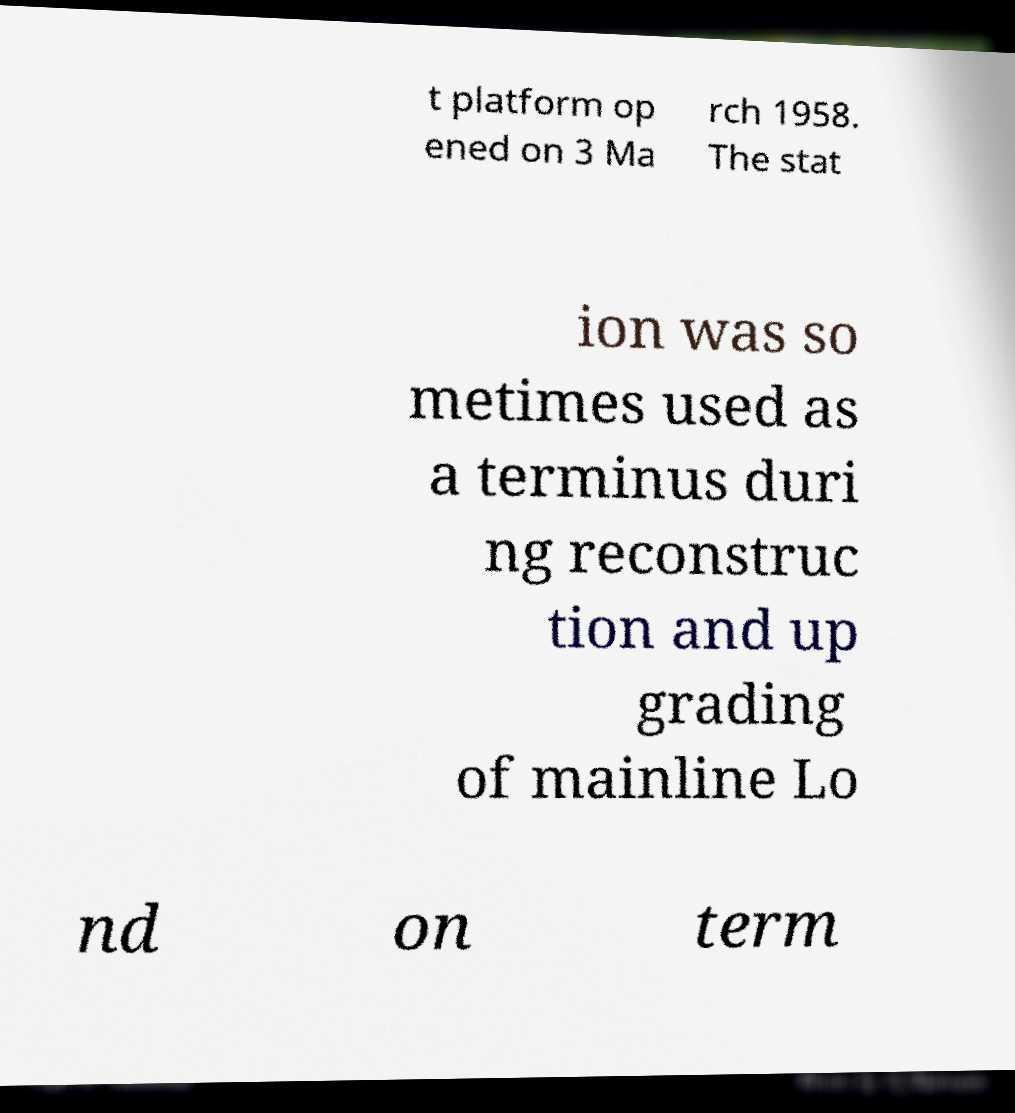Please identify and transcribe the text found in this image. t platform op ened on 3 Ma rch 1958. The stat ion was so metimes used as a terminus duri ng reconstruc tion and up grading of mainline Lo nd on term 